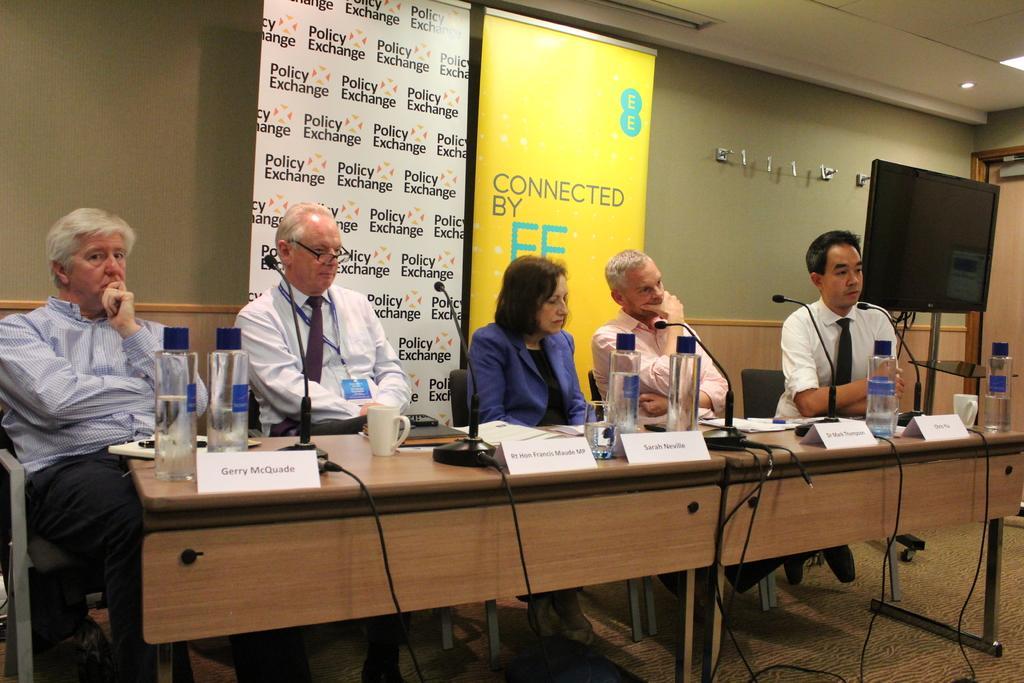In one or two sentences, can you explain what this image depicts? In this image there are people sitting on the chairs. In front of them there is a table. On top of the table there are water bottles, cups, mike's, name boards, glasses, pens, papers. At the bottom of the image there is a floor. In the background of the image there is a wall. On the right side of the image there is a TV. There are banners. On top of the image there are lights. 